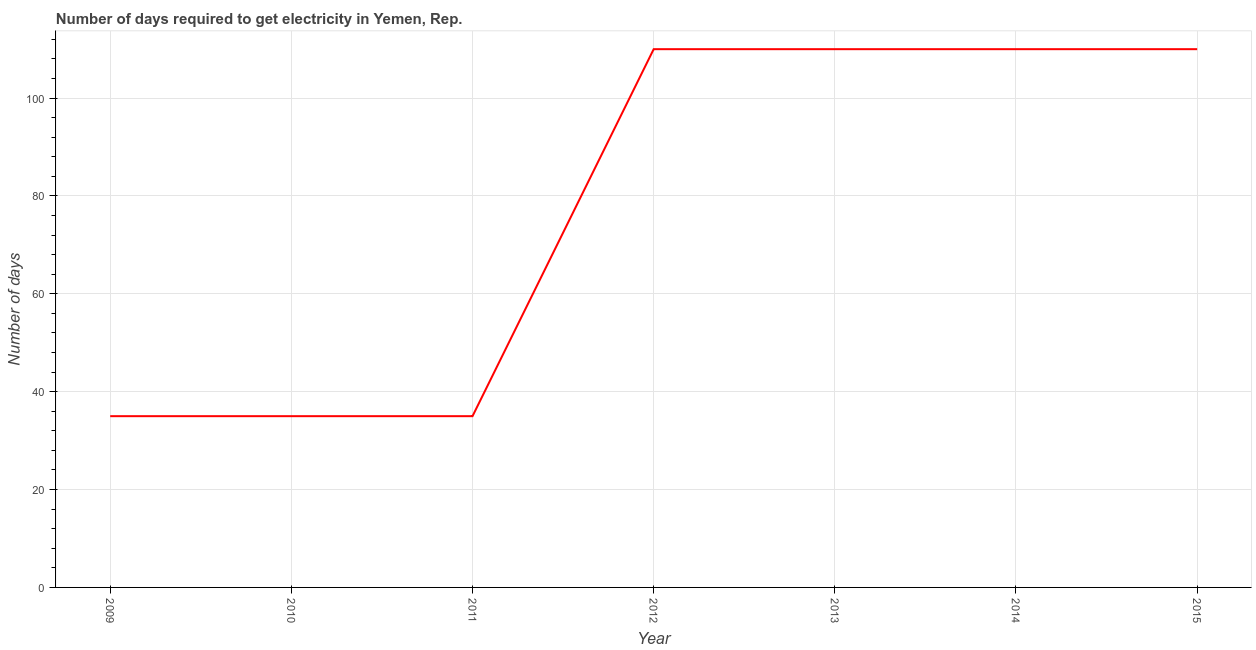What is the time to get electricity in 2011?
Give a very brief answer. 35. Across all years, what is the maximum time to get electricity?
Give a very brief answer. 110. Across all years, what is the minimum time to get electricity?
Your answer should be compact. 35. In which year was the time to get electricity maximum?
Give a very brief answer. 2012. In which year was the time to get electricity minimum?
Your answer should be compact. 2009. What is the sum of the time to get electricity?
Make the answer very short. 545. What is the difference between the time to get electricity in 2011 and 2014?
Your response must be concise. -75. What is the average time to get electricity per year?
Offer a terse response. 77.86. What is the median time to get electricity?
Your response must be concise. 110. Do a majority of the years between 2012 and 2014 (inclusive) have time to get electricity greater than 76 ?
Give a very brief answer. Yes. What is the difference between the highest and the lowest time to get electricity?
Keep it short and to the point. 75. In how many years, is the time to get electricity greater than the average time to get electricity taken over all years?
Make the answer very short. 4. How many years are there in the graph?
Ensure brevity in your answer.  7. Are the values on the major ticks of Y-axis written in scientific E-notation?
Give a very brief answer. No. What is the title of the graph?
Offer a terse response. Number of days required to get electricity in Yemen, Rep. What is the label or title of the Y-axis?
Offer a very short reply. Number of days. What is the Number of days in 2012?
Provide a short and direct response. 110. What is the Number of days of 2013?
Offer a terse response. 110. What is the Number of days in 2014?
Make the answer very short. 110. What is the Number of days in 2015?
Your answer should be compact. 110. What is the difference between the Number of days in 2009 and 2010?
Provide a short and direct response. 0. What is the difference between the Number of days in 2009 and 2012?
Give a very brief answer. -75. What is the difference between the Number of days in 2009 and 2013?
Make the answer very short. -75. What is the difference between the Number of days in 2009 and 2014?
Make the answer very short. -75. What is the difference between the Number of days in 2009 and 2015?
Offer a terse response. -75. What is the difference between the Number of days in 2010 and 2011?
Your answer should be very brief. 0. What is the difference between the Number of days in 2010 and 2012?
Keep it short and to the point. -75. What is the difference between the Number of days in 2010 and 2013?
Provide a short and direct response. -75. What is the difference between the Number of days in 2010 and 2014?
Offer a very short reply. -75. What is the difference between the Number of days in 2010 and 2015?
Keep it short and to the point. -75. What is the difference between the Number of days in 2011 and 2012?
Provide a short and direct response. -75. What is the difference between the Number of days in 2011 and 2013?
Make the answer very short. -75. What is the difference between the Number of days in 2011 and 2014?
Provide a succinct answer. -75. What is the difference between the Number of days in 2011 and 2015?
Keep it short and to the point. -75. What is the difference between the Number of days in 2012 and 2014?
Give a very brief answer. 0. What is the difference between the Number of days in 2012 and 2015?
Provide a short and direct response. 0. What is the difference between the Number of days in 2013 and 2014?
Your answer should be very brief. 0. What is the difference between the Number of days in 2014 and 2015?
Offer a very short reply. 0. What is the ratio of the Number of days in 2009 to that in 2012?
Your answer should be compact. 0.32. What is the ratio of the Number of days in 2009 to that in 2013?
Ensure brevity in your answer.  0.32. What is the ratio of the Number of days in 2009 to that in 2014?
Provide a short and direct response. 0.32. What is the ratio of the Number of days in 2009 to that in 2015?
Ensure brevity in your answer.  0.32. What is the ratio of the Number of days in 2010 to that in 2011?
Your answer should be compact. 1. What is the ratio of the Number of days in 2010 to that in 2012?
Provide a short and direct response. 0.32. What is the ratio of the Number of days in 2010 to that in 2013?
Give a very brief answer. 0.32. What is the ratio of the Number of days in 2010 to that in 2014?
Provide a succinct answer. 0.32. What is the ratio of the Number of days in 2010 to that in 2015?
Ensure brevity in your answer.  0.32. What is the ratio of the Number of days in 2011 to that in 2012?
Your answer should be very brief. 0.32. What is the ratio of the Number of days in 2011 to that in 2013?
Keep it short and to the point. 0.32. What is the ratio of the Number of days in 2011 to that in 2014?
Ensure brevity in your answer.  0.32. What is the ratio of the Number of days in 2011 to that in 2015?
Your answer should be very brief. 0.32. What is the ratio of the Number of days in 2013 to that in 2014?
Your answer should be very brief. 1. 